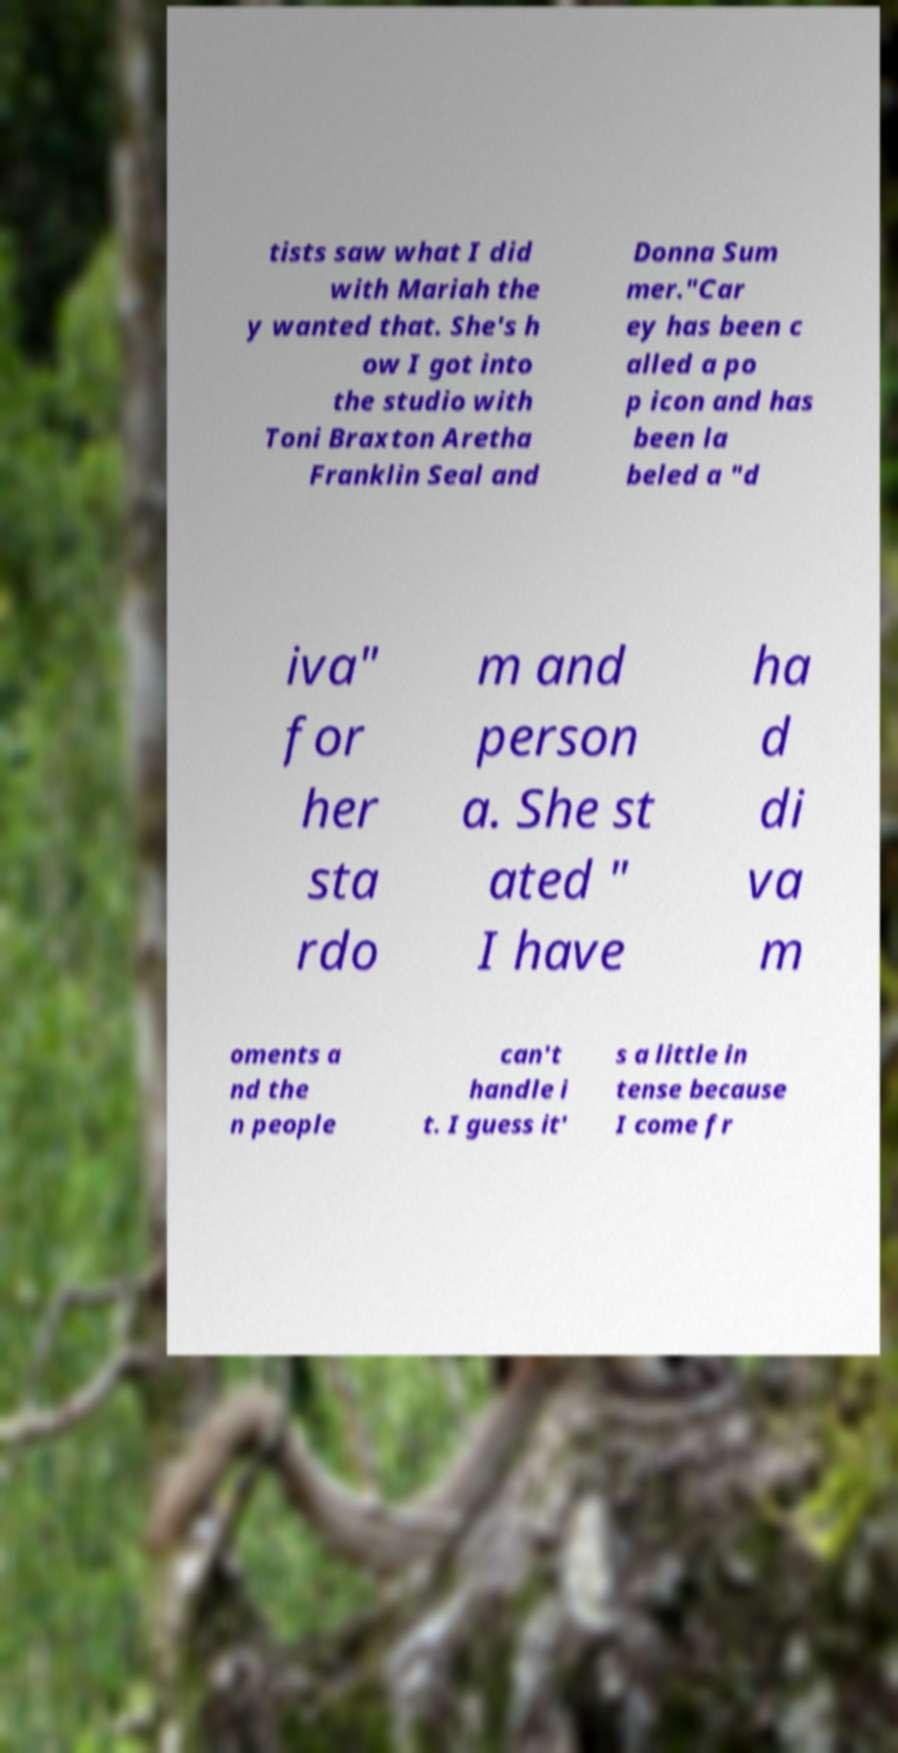Could you extract and type out the text from this image? tists saw what I did with Mariah the y wanted that. She's h ow I got into the studio with Toni Braxton Aretha Franklin Seal and Donna Sum mer."Car ey has been c alled a po p icon and has been la beled a "d iva" for her sta rdo m and person a. She st ated " I have ha d di va m oments a nd the n people can't handle i t. I guess it' s a little in tense because I come fr 